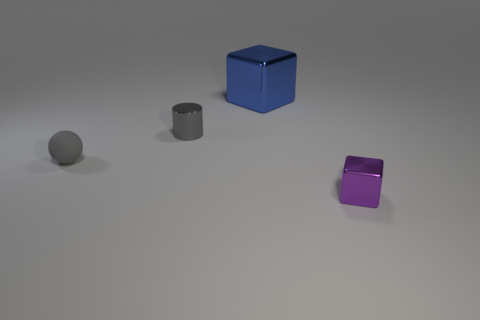Subtract 1 balls. How many balls are left? 0 Add 1 tiny blue shiny objects. How many objects exist? 5 Subtract all cylinders. How many objects are left? 3 Subtract all red cylinders. How many purple cubes are left? 1 Subtract all green shiny blocks. Subtract all blue blocks. How many objects are left? 3 Add 3 metallic cylinders. How many metallic cylinders are left? 4 Add 2 purple metallic blocks. How many purple metallic blocks exist? 3 Subtract 0 red spheres. How many objects are left? 4 Subtract all purple cubes. Subtract all brown balls. How many cubes are left? 1 